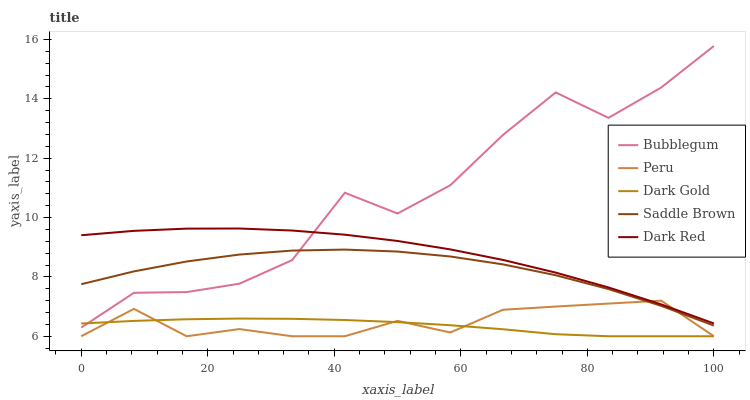Does Dark Gold have the minimum area under the curve?
Answer yes or no. Yes. Does Bubblegum have the maximum area under the curve?
Answer yes or no. Yes. Does Dark Red have the minimum area under the curve?
Answer yes or no. No. Does Dark Red have the maximum area under the curve?
Answer yes or no. No. Is Dark Gold the smoothest?
Answer yes or no. Yes. Is Bubblegum the roughest?
Answer yes or no. Yes. Is Dark Red the smoothest?
Answer yes or no. No. Is Dark Red the roughest?
Answer yes or no. No. Does Peru have the lowest value?
Answer yes or no. Yes. Does Dark Red have the lowest value?
Answer yes or no. No. Does Bubblegum have the highest value?
Answer yes or no. Yes. Does Dark Red have the highest value?
Answer yes or no. No. Is Saddle Brown less than Dark Red?
Answer yes or no. Yes. Is Dark Red greater than Dark Gold?
Answer yes or no. Yes. Does Bubblegum intersect Dark Red?
Answer yes or no. Yes. Is Bubblegum less than Dark Red?
Answer yes or no. No. Is Bubblegum greater than Dark Red?
Answer yes or no. No. Does Saddle Brown intersect Dark Red?
Answer yes or no. No. 